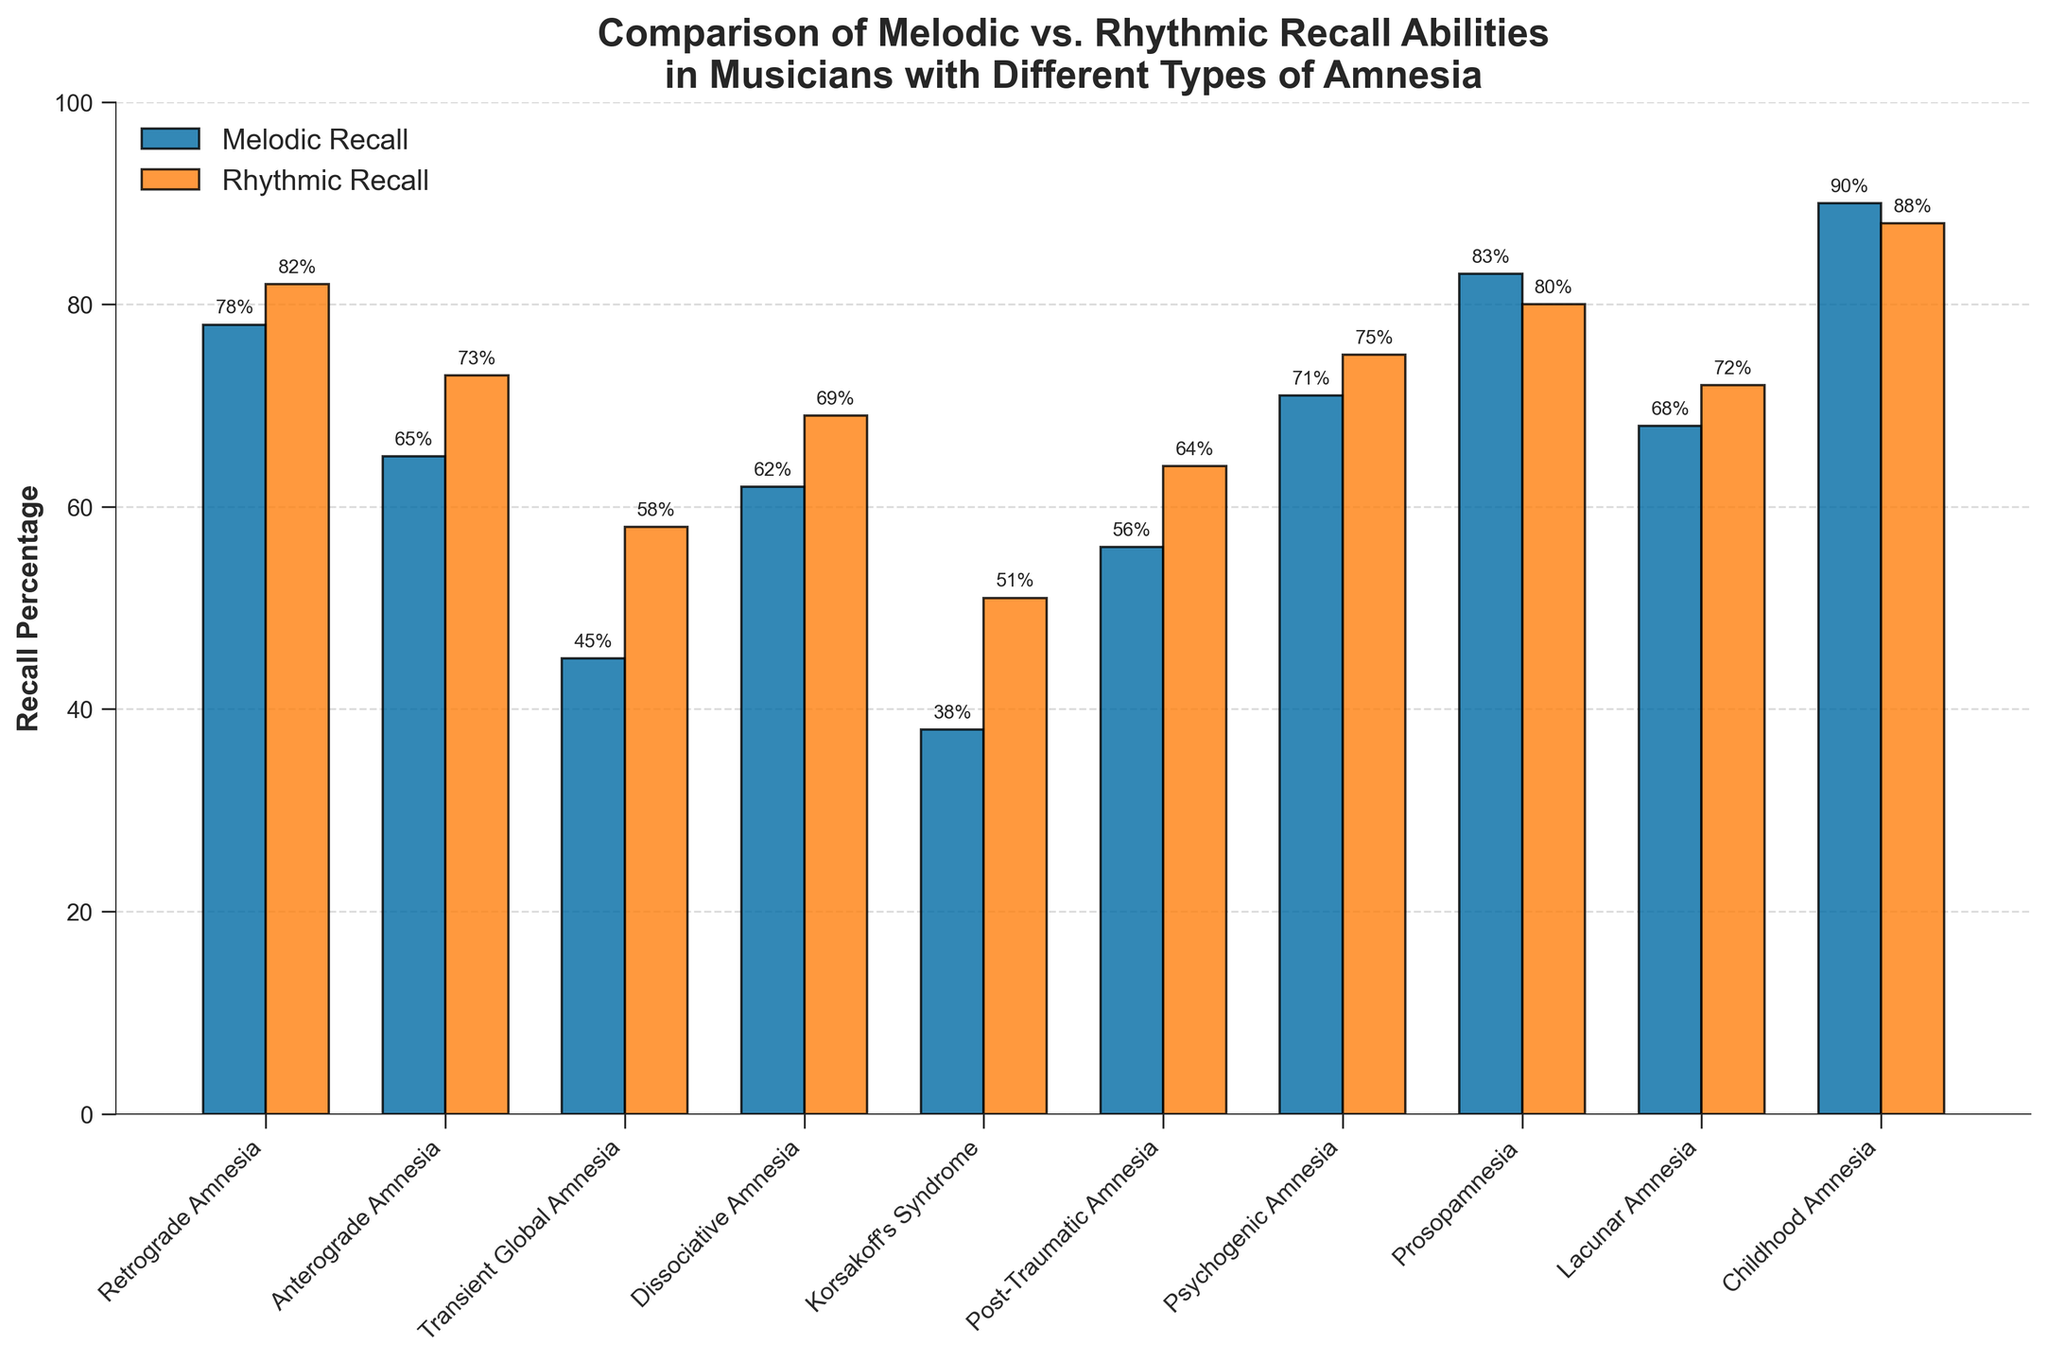What percentage of musicians with Retrograde Amnesia recall rhythms? Locate the bar labeled "Retrograde Amnesia" under the "Rhythmic Recall" section. The height of the bar represents the percentage.
Answer: 82% Which type of amnesia has the lowest melodic recall percentage? Compare the heights of all bars under the "Melodic Recall" section and identify the shortest one. Korsakoff's Syndrome has the lowest percentage.
Answer: Korsakoff's Syndrome Are there any types of amnesia where rhythmic recall exceeds melodic recall? For each type of amnesia, compare the height of the "Rhythmic Recall" bar to the "Melodic Recall" bar. Prosopamnesia has higher rhythmic recall than melodic recall.
Answer: Prosopamnesia What is the average rhythmic recall percentage for Anterograde Amnesia and Dissociative Amnesia? Add the rhythmic recall percentages for Anterograde Amnesia (73%) and Dissociative Amnesia (69%) and divide by 2. (73 + 69) / 2 = 71
Answer: 71 Is there any amnesia type with exactly equal melodic and rhythmic recall percentages? Look for bars where the heights are identical for both melodic and rhythmic recall. No types have equal percentages.
Answer: No Which type of amnesia shows the largest difference between melodic and rhythmic recall percentages? For each type of amnesia, calculate the absolute difference between the melodic and rhythmic recall percentages. Transient Global Amnesia has the largest difference.
Answer: Transient Global Amnesia What is the total recall percentage (sum of melodic and rhythmic) for Childhood Amnesia? Add the melodic recall (90%) and rhythmic recall (88%) percentages for Childhood Amnesia. 90 + 88 = 178
Answer: 178 Between Dissociative Amnesia and Post-Traumatic Amnesia, which has a higher rhythmic recall percentage? Compare the heights of the "Rhythmic Recall" bars for both Dissociative Amnesia (69%) and Post-Traumatic Amnesia (64%). Dissociative Amnesia has a higher percentage.
Answer: Dissociative Amnesia What is the median melodic recall percentage across all types of amnesia? Arrange the melodic recall percentages in ascending order and find the middle value. The ordered values are: 38, 45, 56, 62, 65, 68, 71, 78, 83, 90. The median is (65 + 68) / 2 = 66.5
Answer: 66.5 